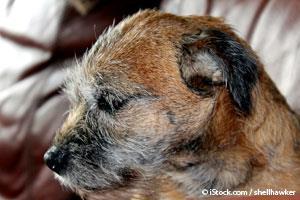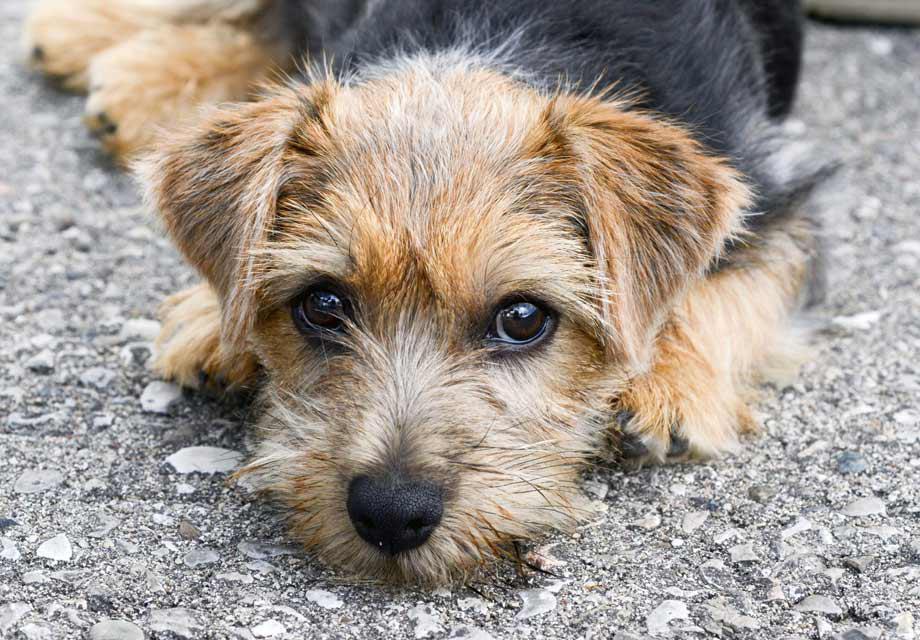The first image is the image on the left, the second image is the image on the right. For the images shown, is this caption "One image shows a dog whose mouth isn't fully closed." true? Answer yes or no. No. The first image is the image on the left, the second image is the image on the right. For the images shown, is this caption "One of the dogs has a body part that is normally inside the mouth being shown outside of the mouth." true? Answer yes or no. No. 